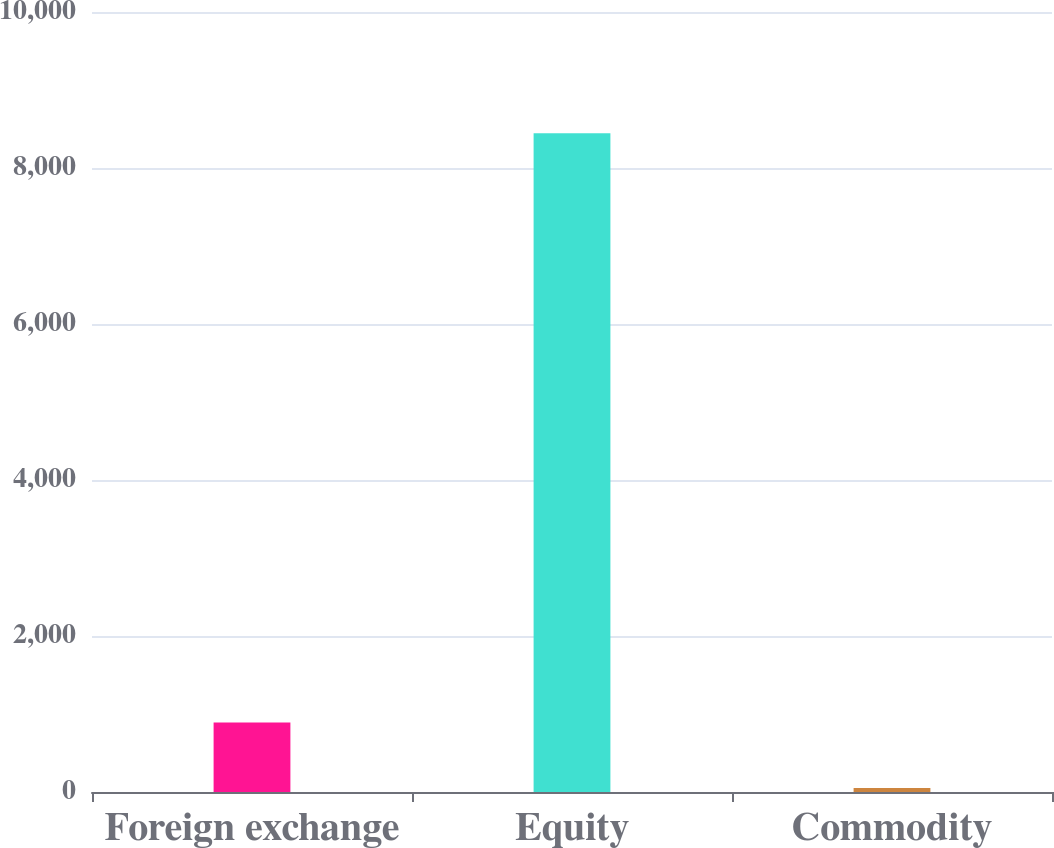<chart> <loc_0><loc_0><loc_500><loc_500><bar_chart><fcel>Foreign exchange<fcel>Equity<fcel>Commodity<nl><fcel>889.7<fcel>8447<fcel>50<nl></chart> 